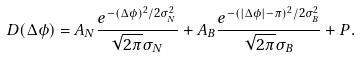Convert formula to latex. <formula><loc_0><loc_0><loc_500><loc_500>D ( \Delta \phi ) = { A _ { N } } \frac { e ^ { - ( \Delta \phi ) ^ { 2 } / 2 \sigma _ { N } ^ { 2 } } } { \sqrt { 2 \pi } \sigma _ { N } } + { A _ { B } } \frac { e ^ { - ( | \Delta \phi | - \pi ) ^ { 2 } / 2 \sigma _ { B } ^ { 2 } } } { \sqrt { 2 \pi } \sigma _ { B } } + P .</formula> 